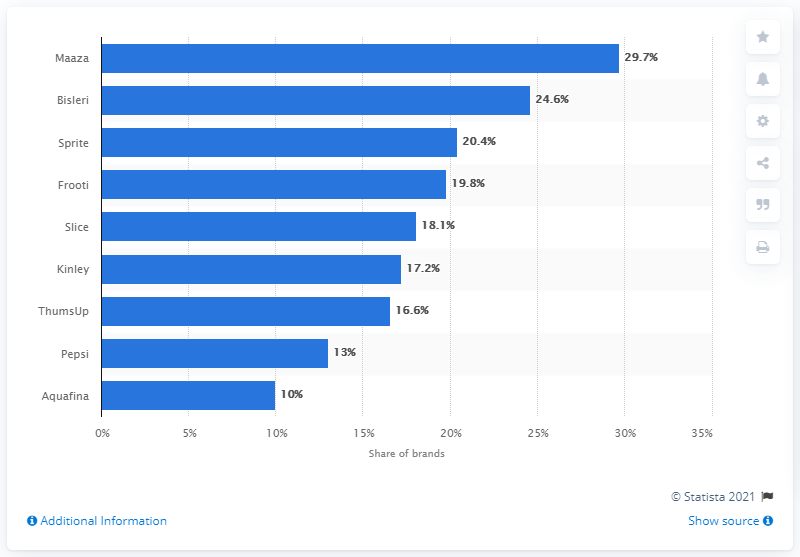Give some essential details in this illustration. The bottled water seller in India is Bisleri. 